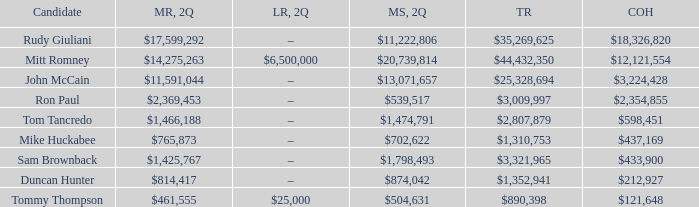Tell me the total receipts for tom tancredo $2,807,879. 